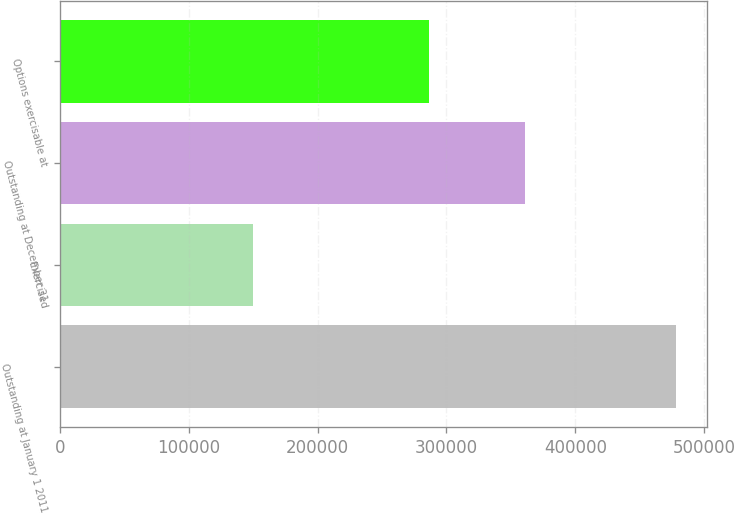<chart> <loc_0><loc_0><loc_500><loc_500><bar_chart><fcel>Outstanding at January 1 2011<fcel>Exercised<fcel>Outstanding at December 31<fcel>Options exercisable at<nl><fcel>478350<fcel>149613<fcel>360611<fcel>286806<nl></chart> 